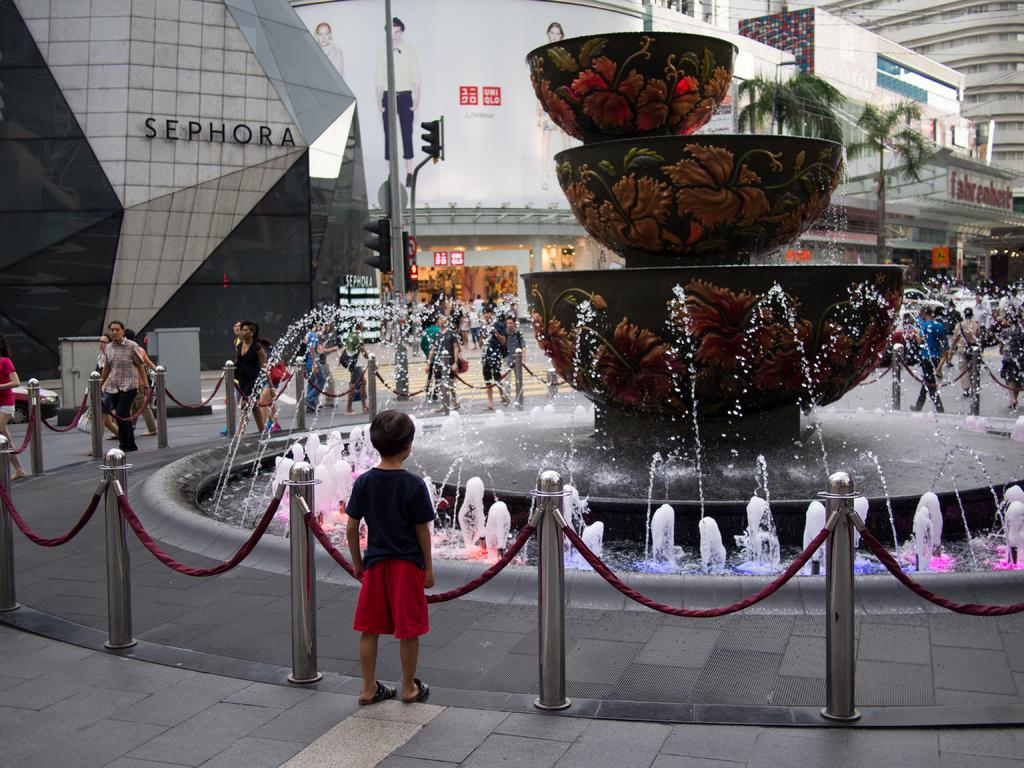<image>
Summarize the visual content of the image. A boy stands in front of a fountain near a Sephora store. 